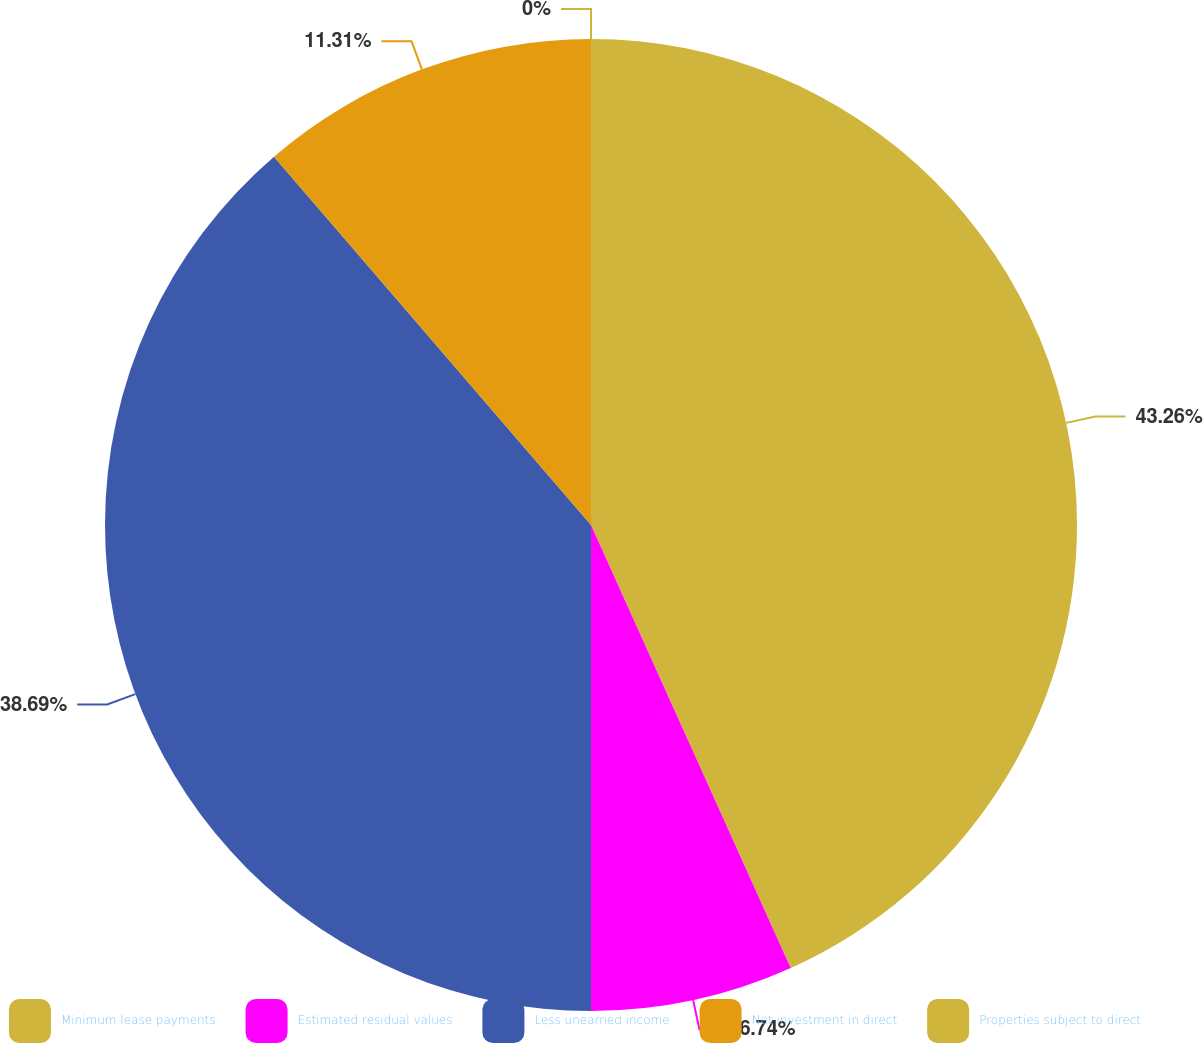Convert chart to OTSL. <chart><loc_0><loc_0><loc_500><loc_500><pie_chart><fcel>Minimum lease payments<fcel>Estimated residual values<fcel>Less unearned income<fcel>Net investment in direct<fcel>Properties subject to direct<nl><fcel>43.26%<fcel>6.74%<fcel>38.69%<fcel>11.31%<fcel>0.0%<nl></chart> 